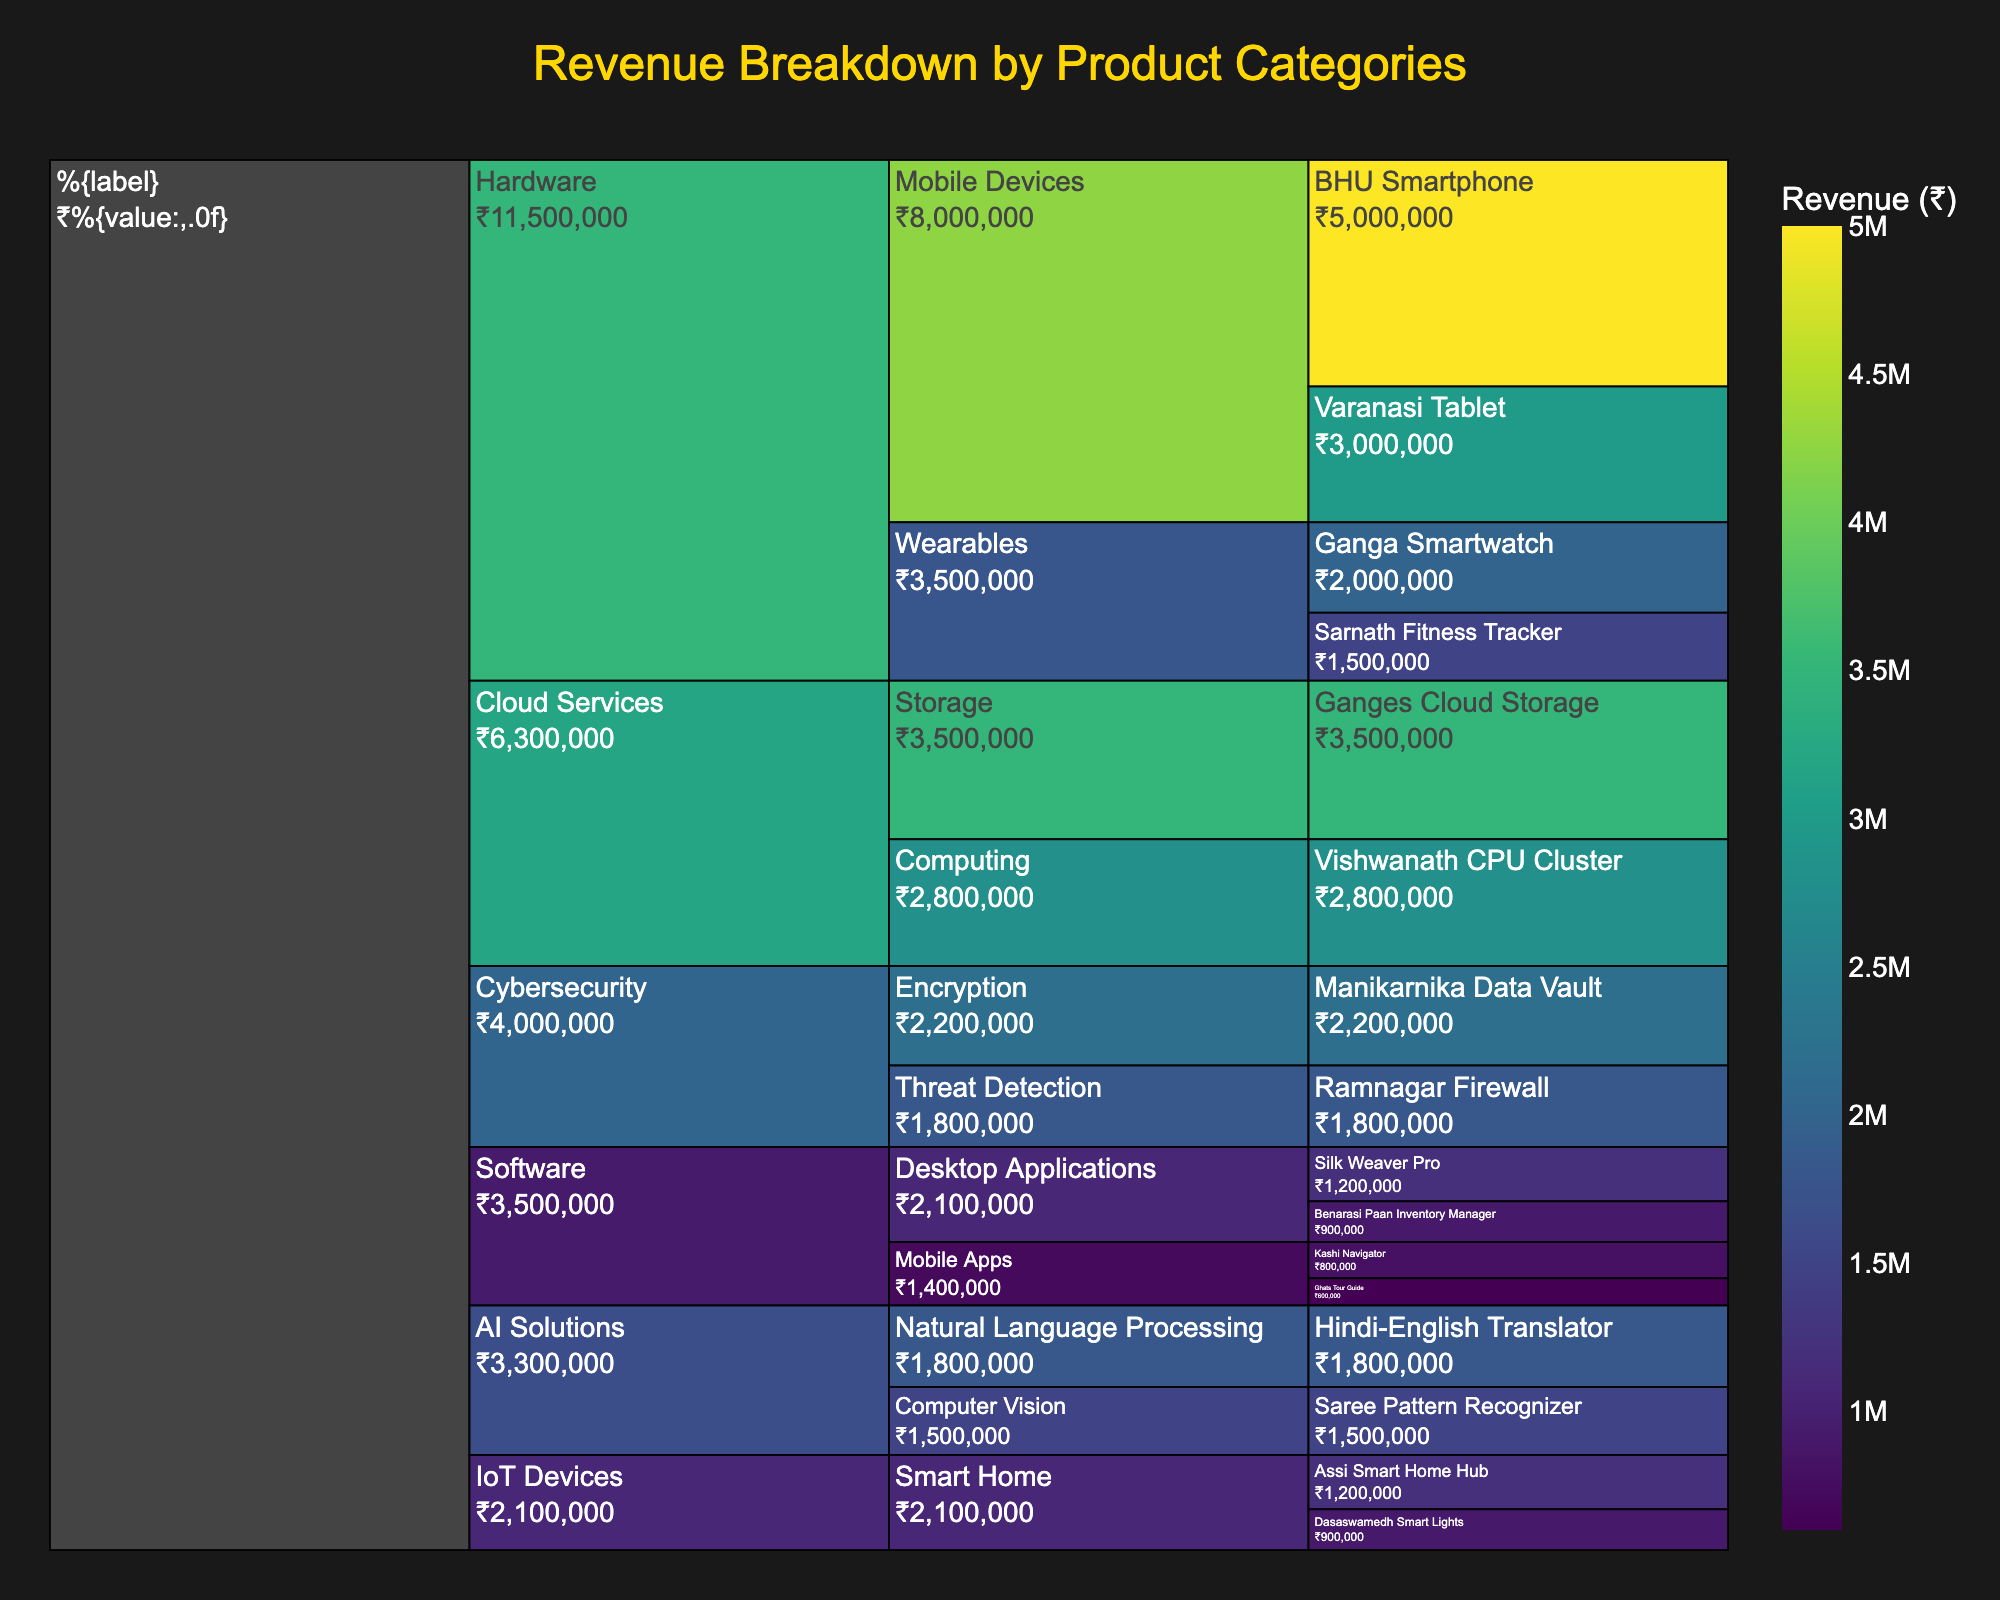What is the title of the icicle chart? The title is usually displayed at the top of the chart, and it provides a concise description of what the chart represents.
Answer: "Revenue Breakdown by Product Categories" Which product in the Mobile Devices subcategory has the highest revenue? Under the Mobile Devices subcategory, you would see two products: BHU Smartphone and Varanasi Tablet. Compare the revenue figures for these two products. BHU Smartphone has a higher revenue of ₹5,000,000.
Answer: BHU Smartphone What is the combined revenue of all products in the Software category? The Software category includes Mobile Apps and Desktop Applications. Sum the revenues of all products within these subcategories: Kashi Navigator (₹800,000), Ghats Tour Guide (₹600,000), Silk Weaver Pro (₹1,200,000), Benarasi Paan Inventory Manager (₹900,000). The combined revenue is ₹3,500,000.
Answer: ₹3,500,000 Which category has the lowest revenue, and what is the total revenue for that category? From the chart, identify the revenues for each main category: Hardware, Software, Cloud Services, AI Solutions, IoT Devices, and Cybersecurity. IoT Devices has the lowest total revenue, summing up the revenue for its subcategories: Assi Smart Home Hub (₹1,200,000) and Dasaswamedh Smart Lights (₹900,000), which equals ₹2,100,000.
Answer: IoT Devices, ₹2,100,000 Compare the revenue of Vishwanath CPU Cluster and Ganges Cloud Storage. Which one is higher? By how much? Locate the two products under the Cloud Services category. Vishwanath CPU Cluster has a revenue of ₹2,800,000 while Ganges Cloud Storage has ₹3,500,000. Subtract the lower revenue from the higher one to find the difference, which is ₹700,000.
Answer: Ganges Cloud Storage, by ₹700,000 What is the total revenue generated by AI Solutions? Identify the subcategories under AI Solutions: Natural Language Processing and Computer Vision. Sum the revenues of their products: Hindi-English Translator (₹1,800,000) and Saree Pattern Recognizer (₹1,500,000). The total revenue is ₹3,300,000.
Answer: ₹3,300,000 Which category contributes most to the overall revenue? Identify the total revenues for each main category displayed in the chart, and determine which one is the highest. Hardware has the highest total revenue, combining Mobile Devices and Wearables.
Answer: Hardware What is the average revenue of products under Encryption in the Cybersecurity category? Encryption has only one product, Manikarnika Data Vault. The revenue is ₹2,200,000, and since there is only one data point, the average is the same as the revenue.
Answer: ₹2,200,000 What's the ratio of the revenue of Hardware to Software? First, find the total revenue of Hardware, combining Mobile Devices (₹8,000,000) and Wearables (₹3,500,000), giving ₹11,500,000. Then find the total revenue for Software, which is ₹3,500,000. The ratio is 11,500,000 to 3,500,000. Simplify this ratio by dividing both numbers by 3,500,000, yielding approximately 3.29.
Answer: 3.29 